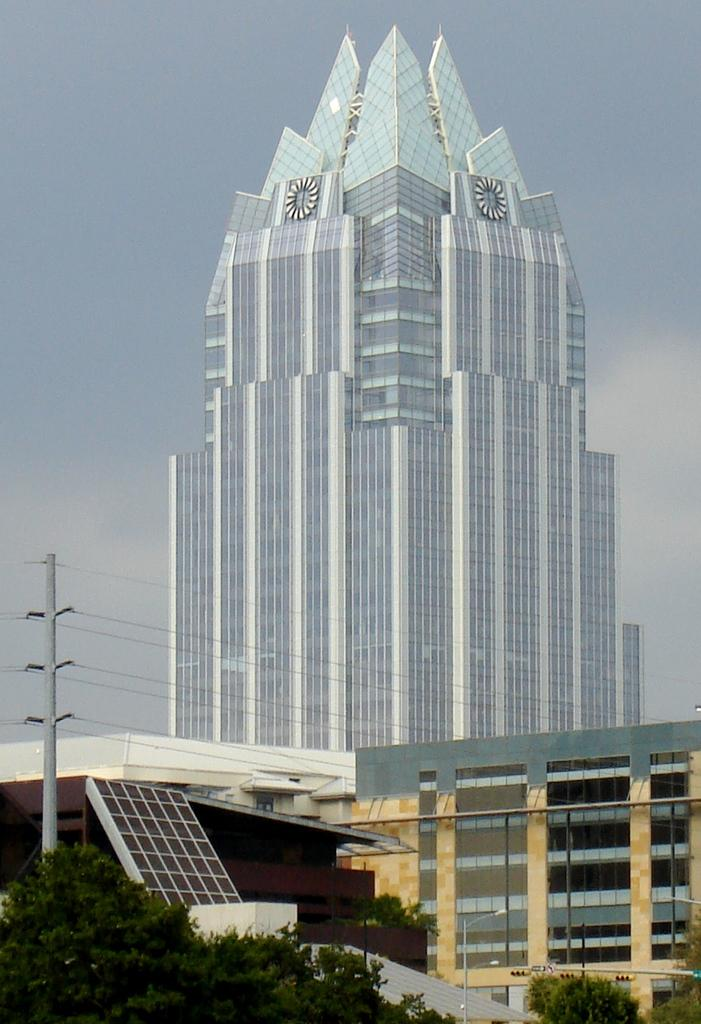What type of structures can be seen in the image? There are buildings with windows in the image. What else is present in the image besides the buildings? There is a pole with wires, a group of trees, and a solar panel in the image. How are the buildings connected to the pole? The pole with wires is likely connected to the buildings for electricity or communication purposes. What is the condition of the sky in the image? The sky is visible in the image and appears cloudy. Where is the sink located in the image? There is no sink present in the image. What group of people can be seen interacting with the solar panel in the image? There are no people visible in the image, so it is impossible to determine if any group is interacting with the solar panel. 